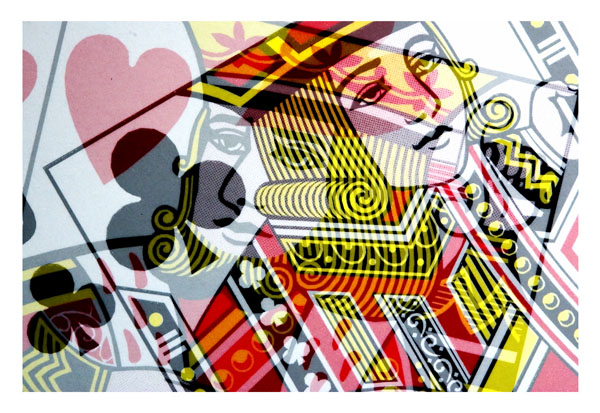What is the main subject of the image?
A. a car
B. a cat
C. playing cards
D. a dog
Answer with the option's letter from the given choices directly. The main subject of the image is option C, playing cards. Specifically, the image features a close-up of a queen playing card in a vividly artistic style, displaying elements like the face, crown, and suit symbols prominently. 